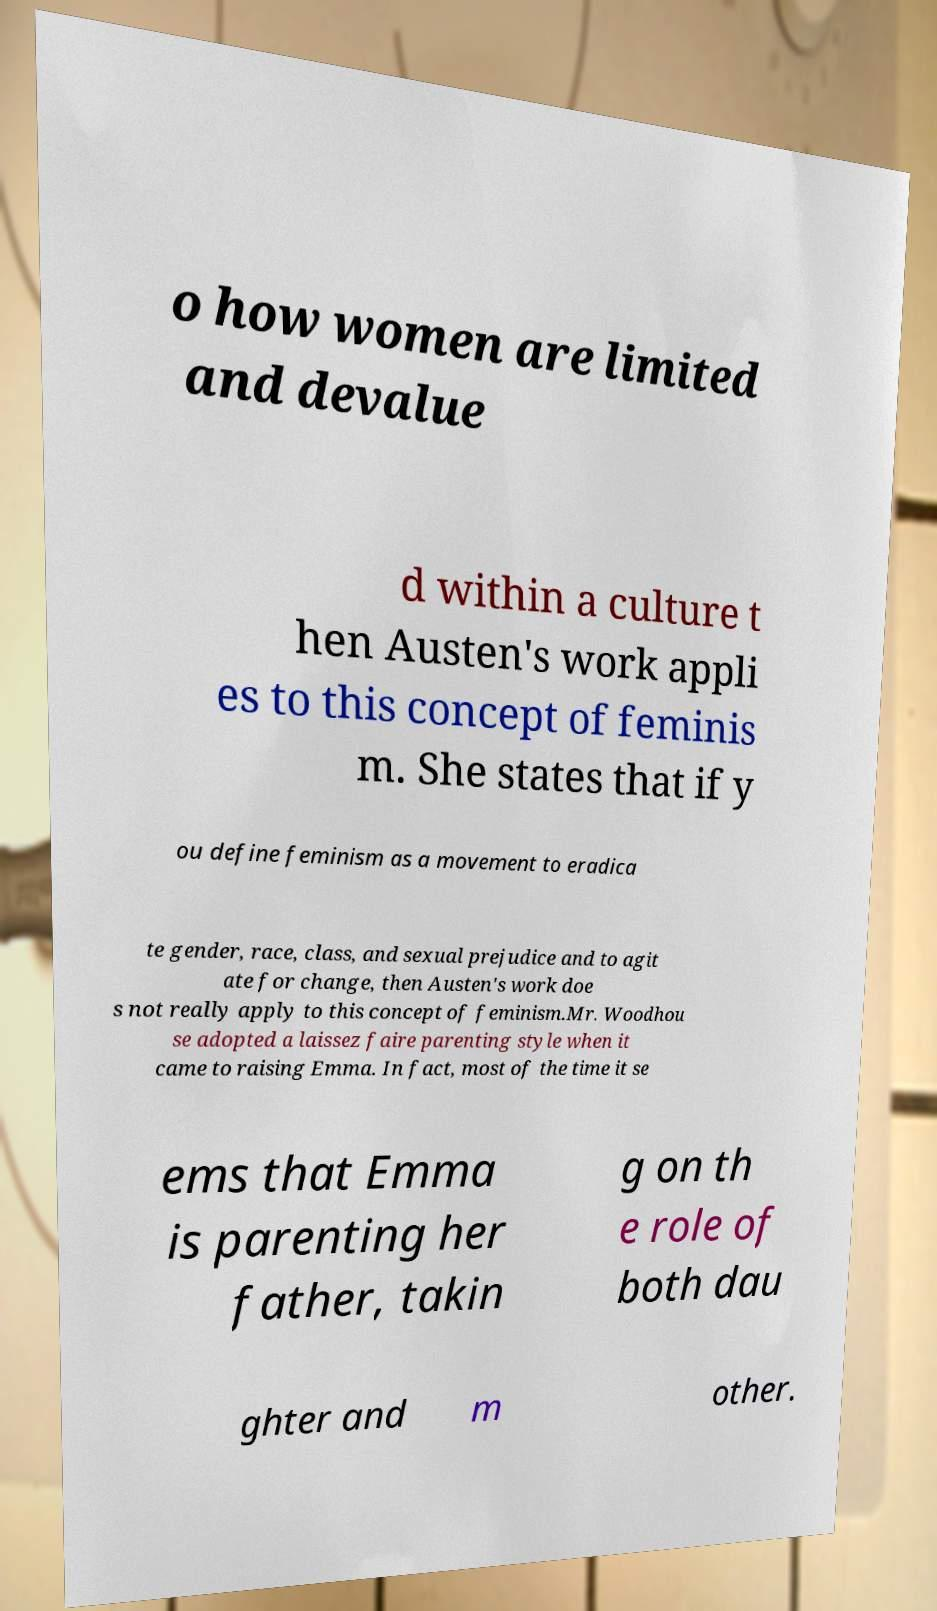I need the written content from this picture converted into text. Can you do that? o how women are limited and devalue d within a culture t hen Austen's work appli es to this concept of feminis m. She states that if y ou define feminism as a movement to eradica te gender, race, class, and sexual prejudice and to agit ate for change, then Austen's work doe s not really apply to this concept of feminism.Mr. Woodhou se adopted a laissez faire parenting style when it came to raising Emma. In fact, most of the time it se ems that Emma is parenting her father, takin g on th e role of both dau ghter and m other. 